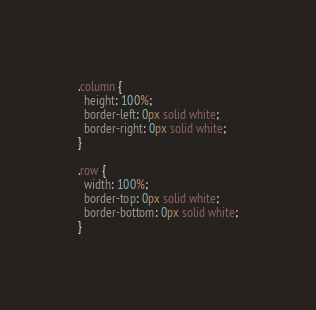<code> <loc_0><loc_0><loc_500><loc_500><_CSS_>.column {
  height: 100%;
  border-left: 0px solid white;
  border-right: 0px solid white;
}

.row {
  width: 100%;
  border-top: 0px solid white;
  border-bottom: 0px solid white;
}
</code> 